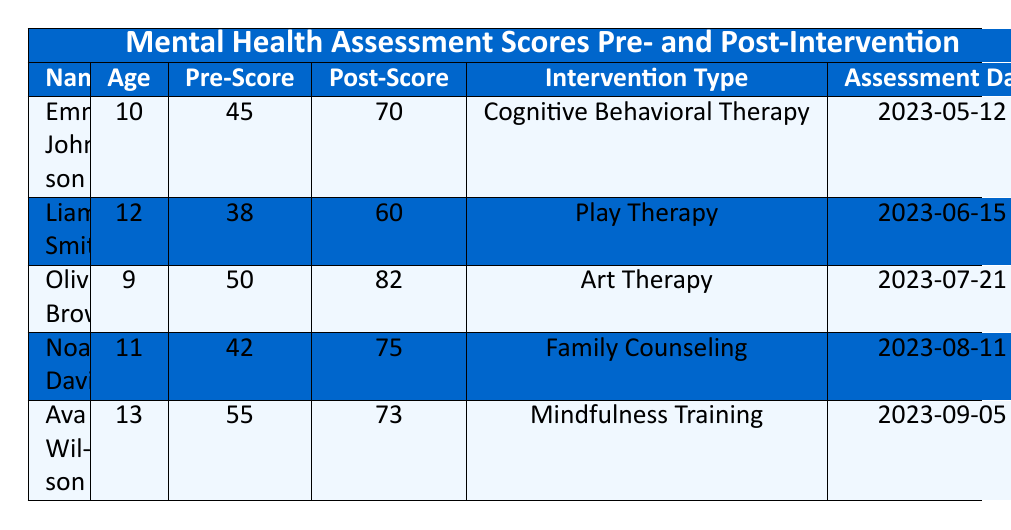What is the highest post-intervention score recorded in the table? Examining the Post-Score column, the scores are 70, 60, 82, 75, and 73. The highest number among these is 82, recorded for Olivia Brown.
Answer: 82 Which child had the lowest pre-intervention score? Looking at the Pre-Score column, the scores are 45, 38, 50, 42, and 55. The lowest score is 38, which belongs to Liam Smith.
Answer: Liam Smith What was the average increase in scores after the intervention? To find the average increase, subtract each individual pre-intervention score from the corresponding post-intervention score: (70-45) + (60-38) + (82-50) + (75-42) + (73-55) = 25 + 22 + 32 + 33 + 18 = 130. Then divide by the number of children (5): 130/5 = 26.
Answer: 26 Did any child utilize Cognitive Behavioral Therapy? The table lists the intervention types, and we see that Emma Johnson underwent Cognitive Behavioral Therapy. Therefore, the answer is yes.
Answer: Yes What is the median pre-intervention score among all children? The Pre-Scores arranged in order are 38, 42, 45, 50, and 55. Since there are five data points, the median is the third value, which is 45.
Answer: 45 Which intervention type had the highest post-intervention score? Comparing post-intervention scores of each type: Cognitive Behavioral Therapy (70), Play Therapy (60), Art Therapy (82), Family Counseling (75), and Mindfulness Training (73). Art Therapy has the highest score of 82.
Answer: Art Therapy Which child experienced the least improvement in their score? Calculate the score improvement for each child: Emma Johnson (25), Liam Smith (22), Olivia Brown (32), Noah Davis (33), Ava Wilson (18). The least improvement is seen with Ava Wilson at 18 points.
Answer: Ava Wilson Was there any child who had a pre-intervention score of 50 or above? Checking the Pre-Score column, we find scores of 45, 38, 50, 42, and 55. The last two scores, 50 and 55, confirm that there were indeed children with scores of 50 or higher.
Answer: Yes What is the total number of children assessed? Reviewing the table, we can count the entries: there are 5 children listed in total. Therefore, the total number of children assessed is 5.
Answer: 5 